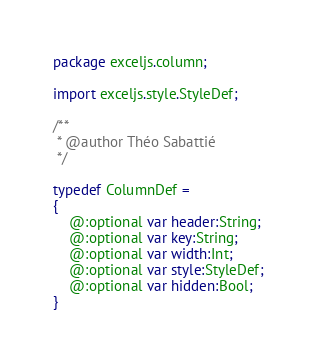Convert code to text. <code><loc_0><loc_0><loc_500><loc_500><_Haxe_>package exceljs.column;

import exceljs.style.StyleDef;

/**
 * @author Théo Sabattié
 */

typedef ColumnDef =
{
    @:optional var header:String;
    @:optional var key:String;
    @:optional var width:Int;
    @:optional var style:StyleDef;
    @:optional var hidden:Bool;	
}</code> 